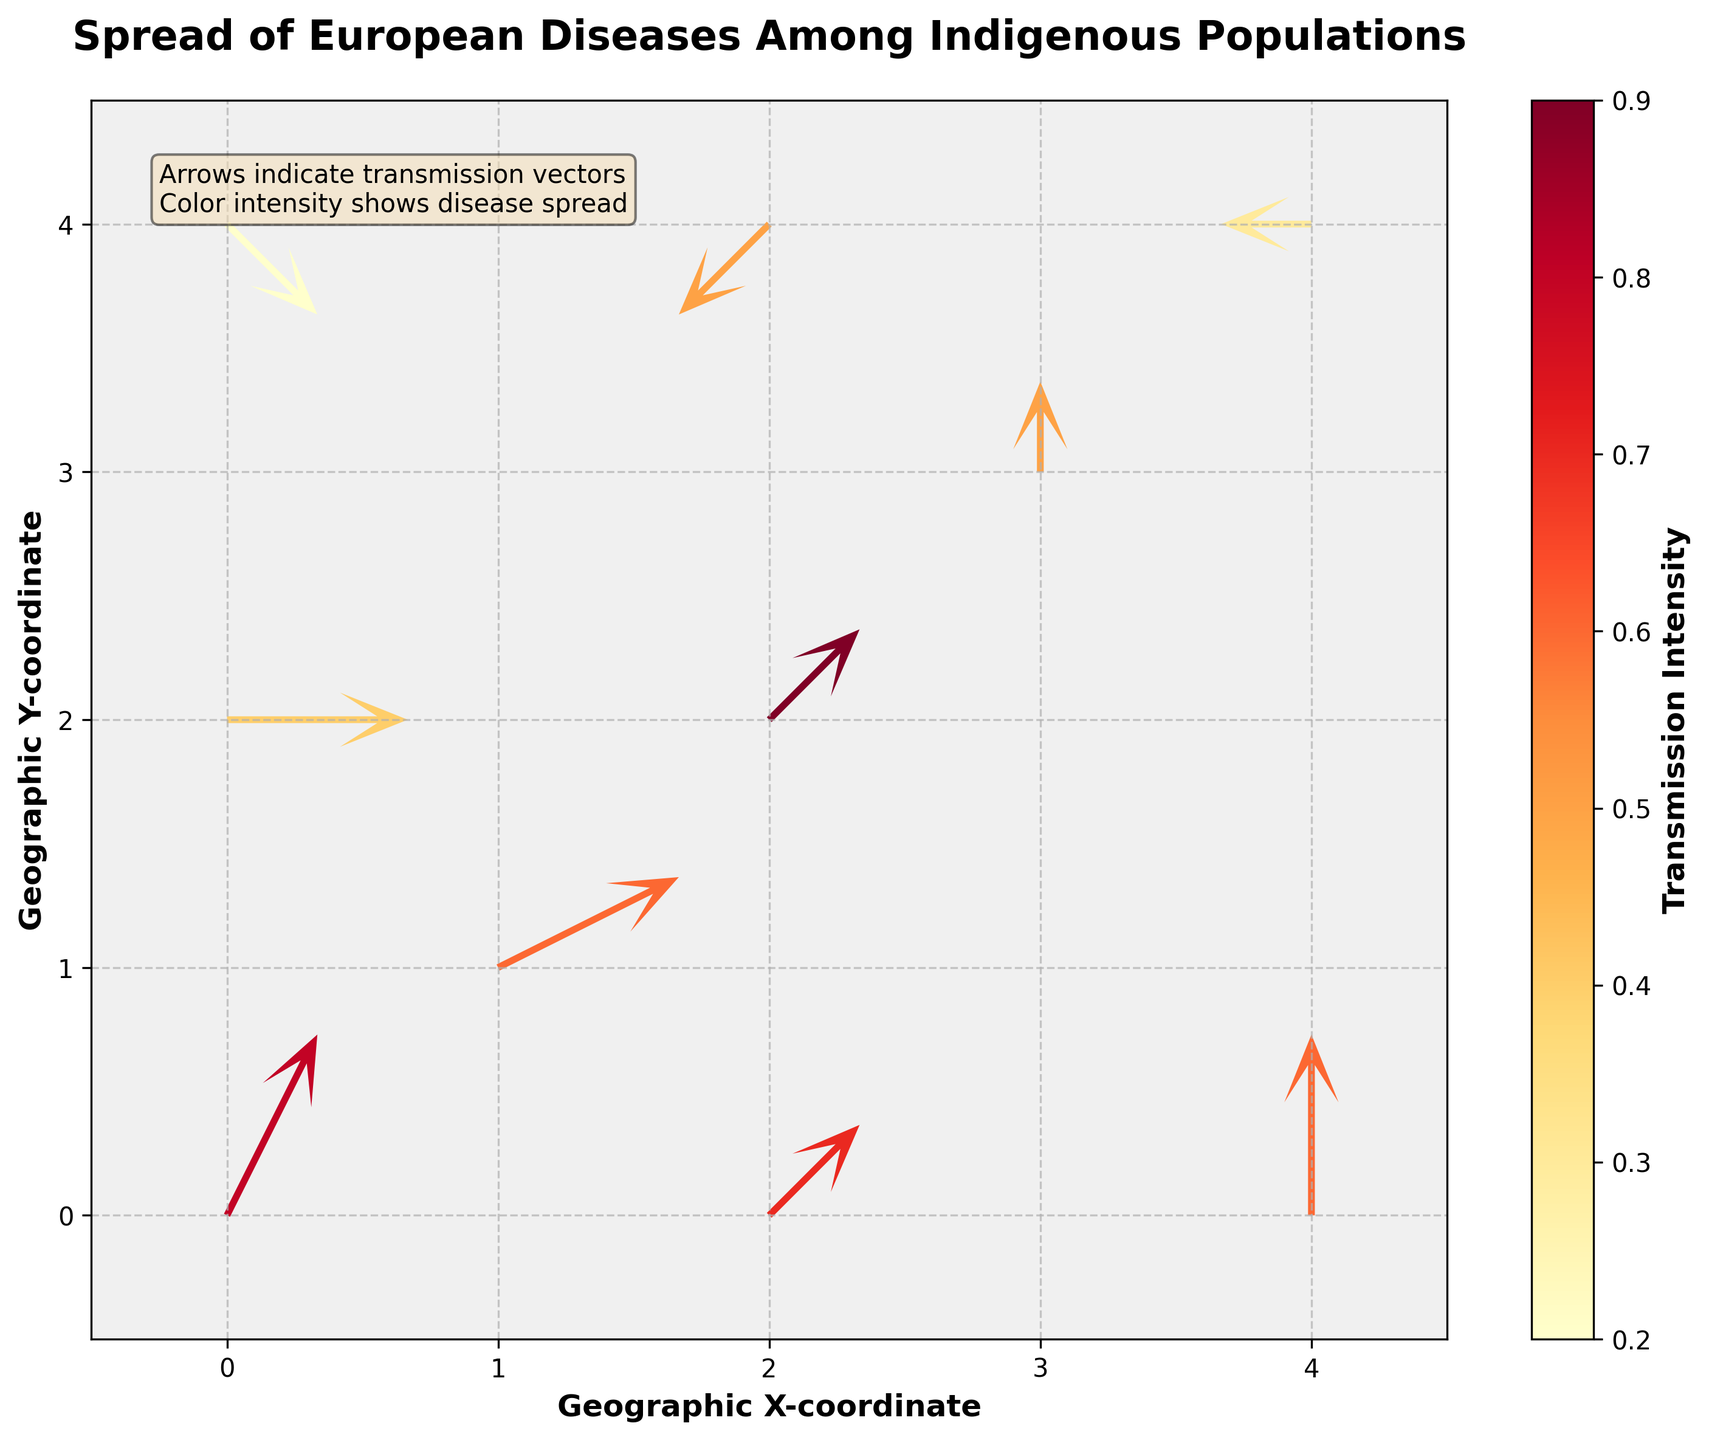What is the title of the figure? The title of a figure is usually found at the very top and describes the main subject of the plot. Here, it reads "Spread of European Diseases Among Indigenous Populations."
Answer: Spread of European Diseases Among Indigenous Populations What do the colors of the arrows represent? In the figure, the color intensity of the arrows represents the "Transmission Intensity" of the diseases. This can be confirmed by the color bar labeled "Transmission Intensity" on the right side of the plot.
Answer: Transmission Intensity Which location has the highest transmission intensity? The location with the highest transmission intensity will have the darkest arrow in the color range used. Upon inspecting the arrows, the arrow at (2,2) is the darkest, corresponding to an intensity of 0.9.
Answer: (2,2) What direction is the arrow at (0,0) pointing? The direction of an arrow in a quiver plot can be broken down into its horizontal (u) and vertical (v) components. For the point (0,0), the components are (1,2), meaning the arrow points to the right and upwards.
Answer: Right and Upwards Which direction is the arrow at (0,4) pointing in? At location (0,4), the u (horizontal) component is 1 and the v (vertical) component is -1, meaning the arrow points to the right and downwards.
Answer: Right and Downwards What is the transmission intensity at the location (4,0)? The color bar and arrow shades indicate the transmission intensity. The data point at (4,0) has an arrow with an intensity corresponding to roughly 0.6, based on the figure and the color map.
Answer: 0.6 Which location has an arrow pointing purely to the right? An arrow pointing purely to the right would have a vertical component (v) of 0. By inspecting the arrows, the location (0,2) meets this criterion, where u=2 and v=0.
Answer: (0,2) Which location has the lowest transmission intensity? The lowest transmission intensity is represented by the least intense color. In the figure, the arrow at (0,4) is the faintest, corresponding to an intensity of 0.2.
Answer: (0,4) Compare the transmission intensities between (1,1) and (4,4). Which is higher? The color of the arrows at (1,1) and (4,4) indicate their respective intensities. The intensity at (1,1) is 0.6, while at (4,4) it is 0.3. Hence, (1,1) has a higher transmission intensity.
Answer: (1,1) 